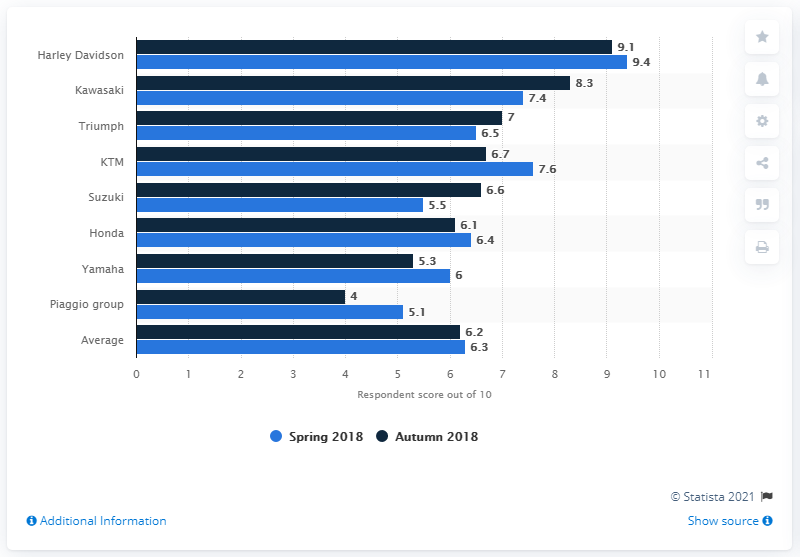Point out several critical features in this image. Harley Davidson was the motorcycle dealer that was most convinced of the high value of their franchise. 